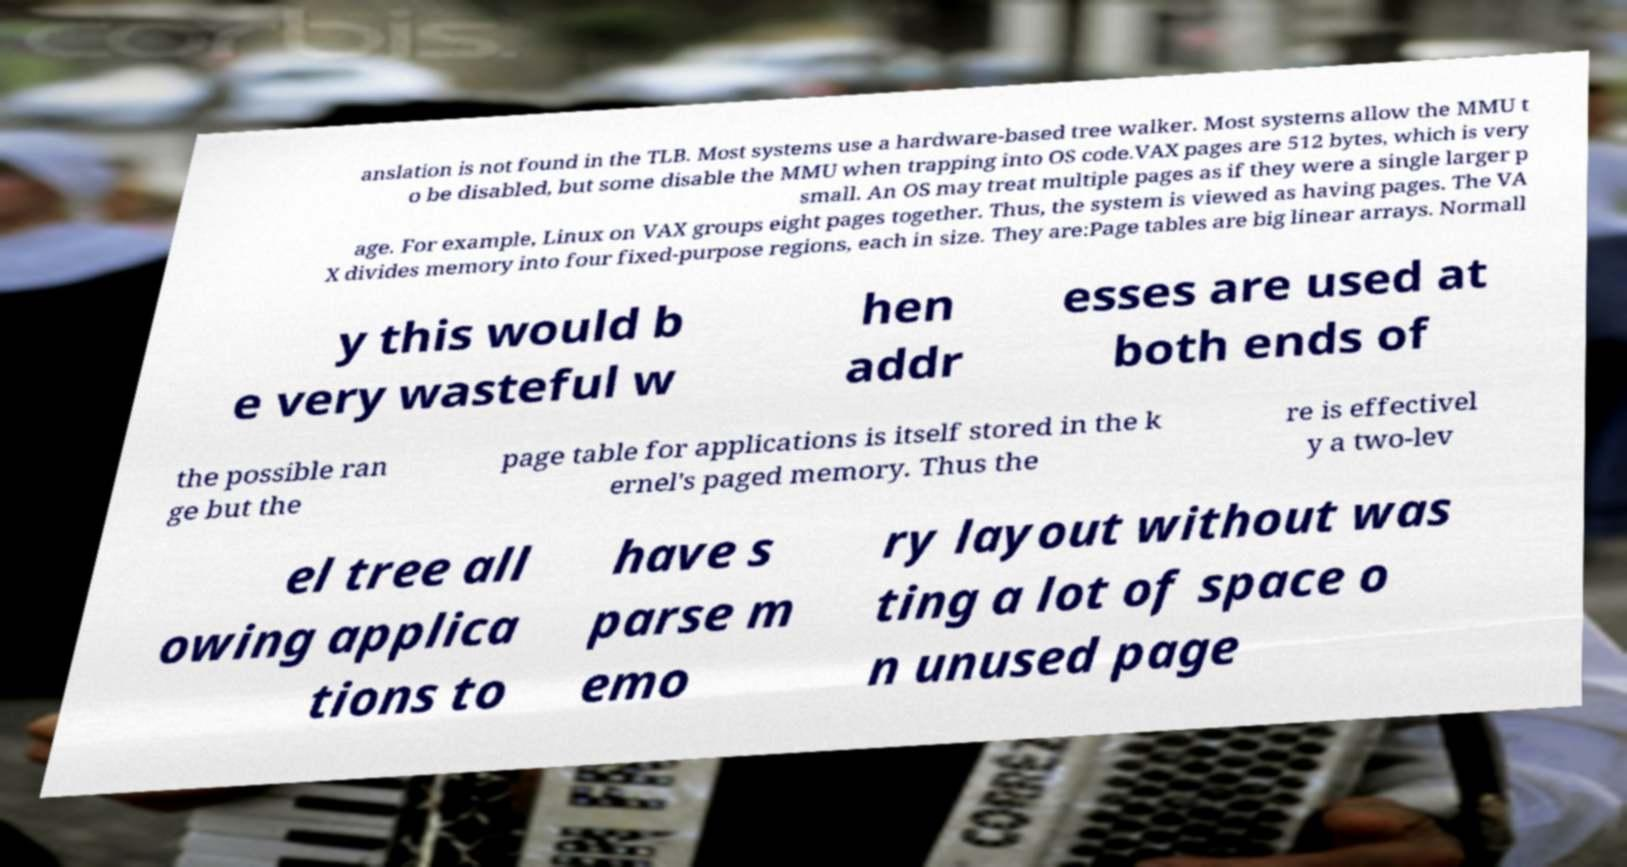Please read and relay the text visible in this image. What does it say? anslation is not found in the TLB. Most systems use a hardware-based tree walker. Most systems allow the MMU t o be disabled, but some disable the MMU when trapping into OS code.VAX pages are 512 bytes, which is very small. An OS may treat multiple pages as if they were a single larger p age. For example, Linux on VAX groups eight pages together. Thus, the system is viewed as having pages. The VA X divides memory into four fixed-purpose regions, each in size. They are:Page tables are big linear arrays. Normall y this would b e very wasteful w hen addr esses are used at both ends of the possible ran ge but the page table for applications is itself stored in the k ernel's paged memory. Thus the re is effectivel y a two-lev el tree all owing applica tions to have s parse m emo ry layout without was ting a lot of space o n unused page 